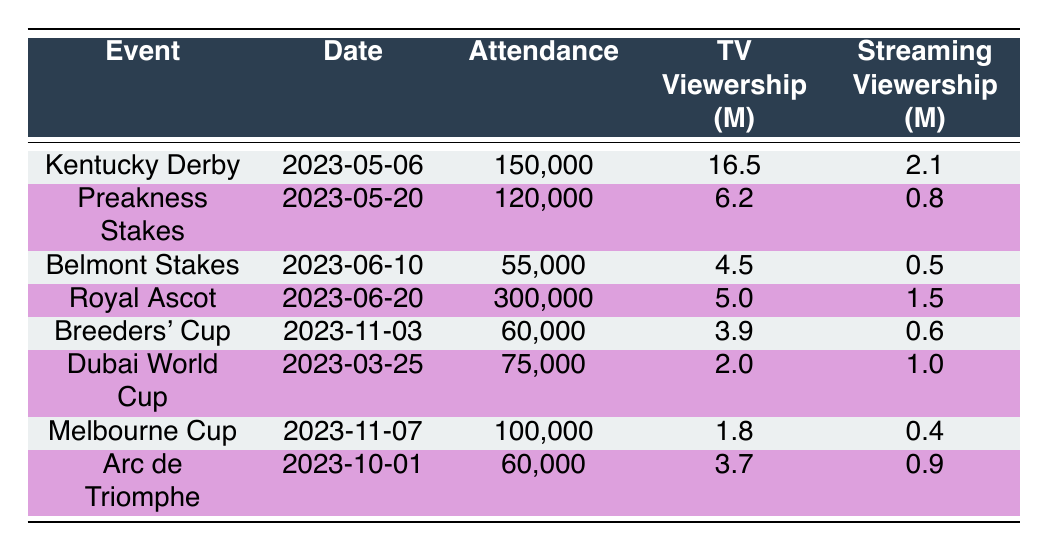What is the date of the Kentucky Derby? The date listed in the table next to the event name "Kentucky Derby" is 2023-05-06.
Answer: 2023-05-06 Which event had the highest attendance in 2023? The highest attendance is listed for the "Royal Ascot" event with 300,000 attendees.
Answer: Royal Ascot What is the total television viewership (in millions) for the Belmont Stakes and Breeders' Cup combined? For the Belmont Stakes, television viewership is 4.5 million and for the Breeders' Cup, it is 3.9 million. Adding these gives 4.5 + 3.9 = 8.4 million.
Answer: 8.4 million Did the Dubai World Cup have more streaming viewership than the Melbourne Cup? The streaming viewership for the Dubai World Cup is 1.0 million and for the Melbourne Cup, it's 0.4 million. Since 1.0 is greater than 0.4, the statement is true.
Answer: Yes How many events had an attendance of less than 100,000? The events with attendance less than 100,000 are the "Belmont Stakes" (55,000), "Breeders' Cup" (60,000), "Arc de Triomphe" (60,000), and "Melbourne Cup" (100,000), making the count of events with an attendance below 100,000 total four.
Answer: 4 